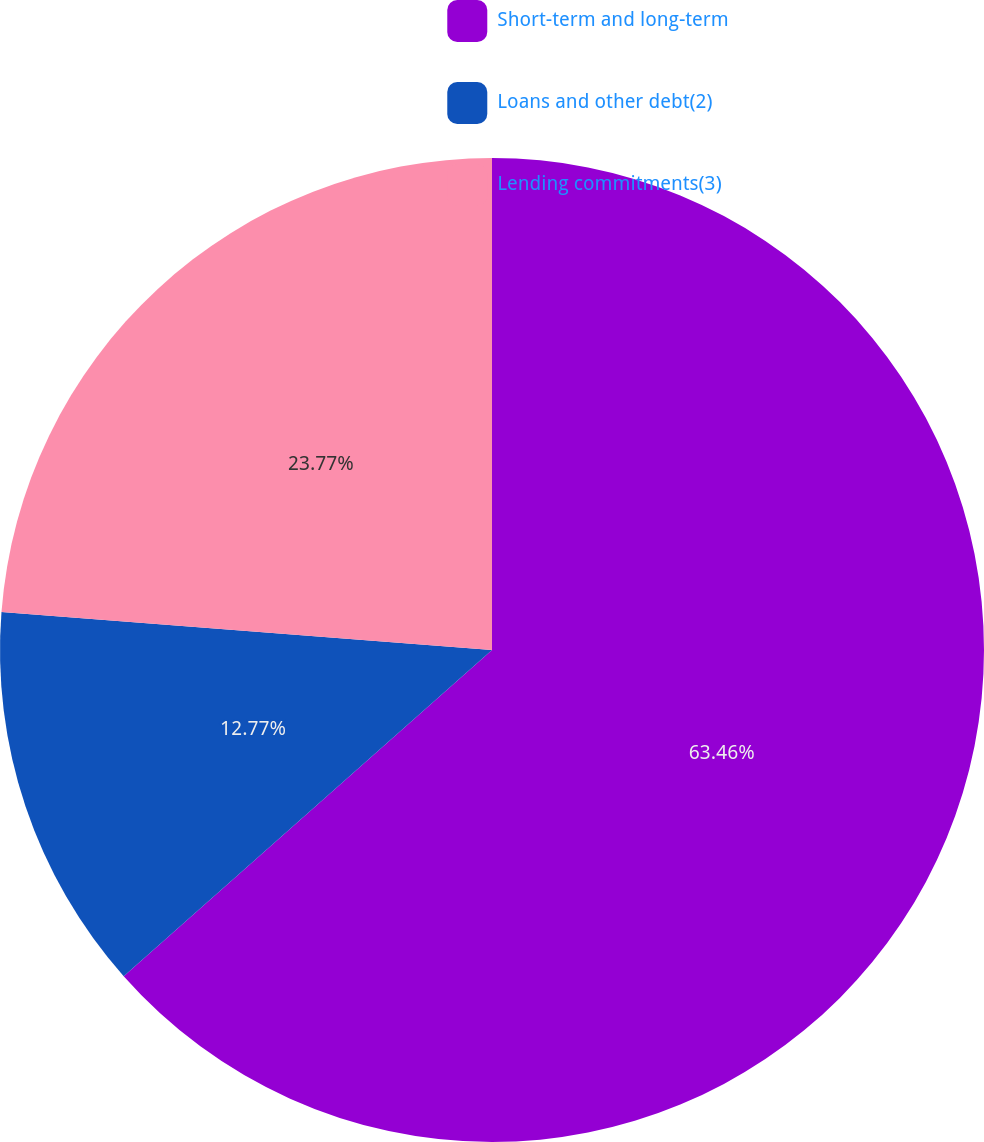<chart> <loc_0><loc_0><loc_500><loc_500><pie_chart><fcel>Short-term and long-term<fcel>Loans and other debt(2)<fcel>Lending commitments(3)<nl><fcel>63.47%<fcel>12.77%<fcel>23.77%<nl></chart> 